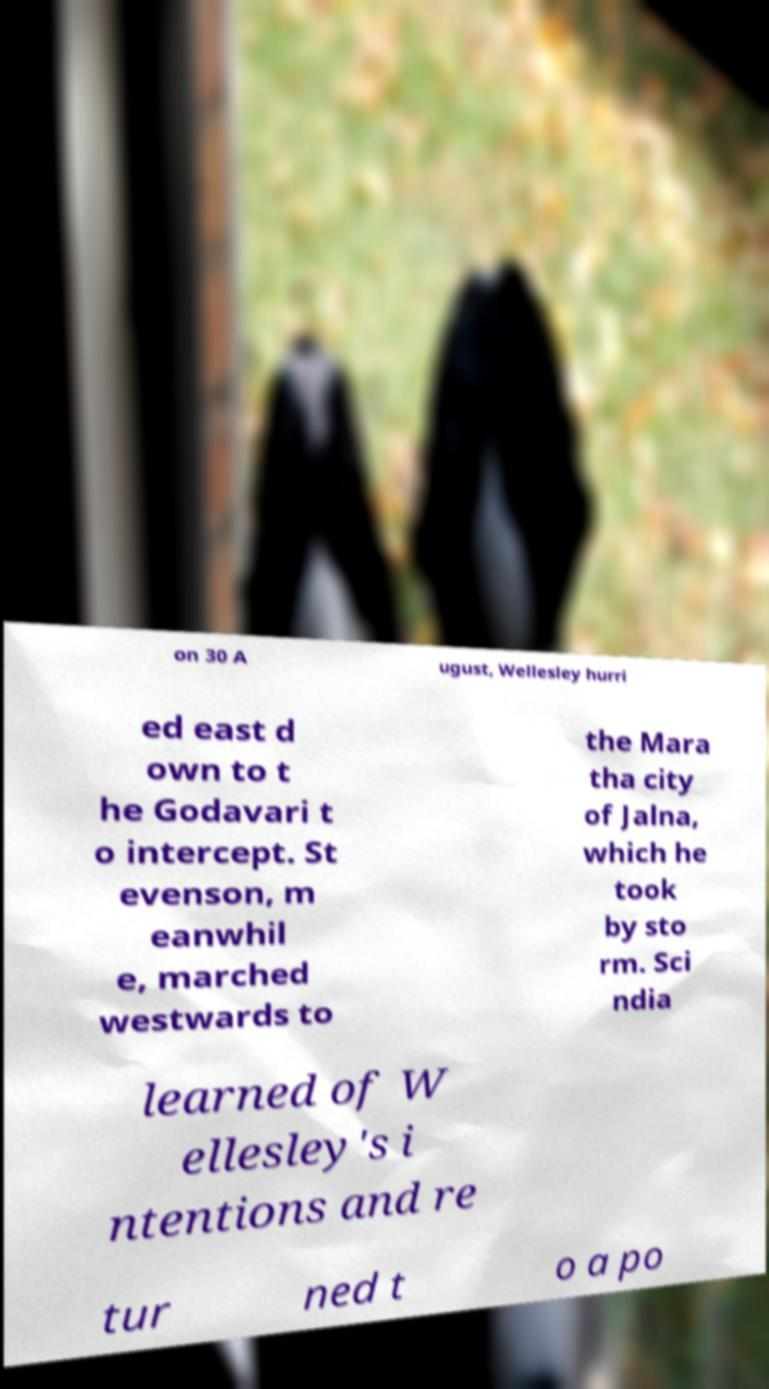Can you accurately transcribe the text from the provided image for me? on 30 A ugust, Wellesley hurri ed east d own to t he Godavari t o intercept. St evenson, m eanwhil e, marched westwards to the Mara tha city of Jalna, which he took by sto rm. Sci ndia learned of W ellesley's i ntentions and re tur ned t o a po 